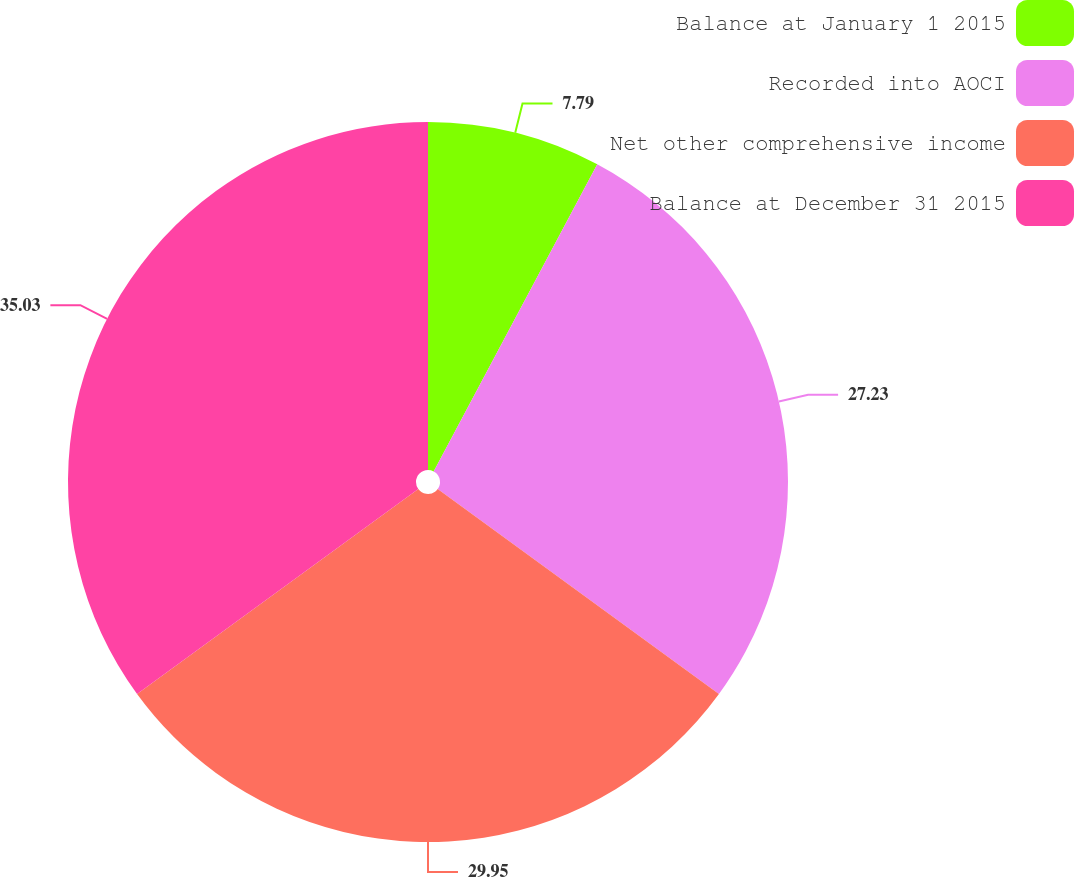Convert chart. <chart><loc_0><loc_0><loc_500><loc_500><pie_chart><fcel>Balance at January 1 2015<fcel>Recorded into AOCI<fcel>Net other comprehensive income<fcel>Balance at December 31 2015<nl><fcel>7.79%<fcel>27.23%<fcel>29.95%<fcel>35.02%<nl></chart> 